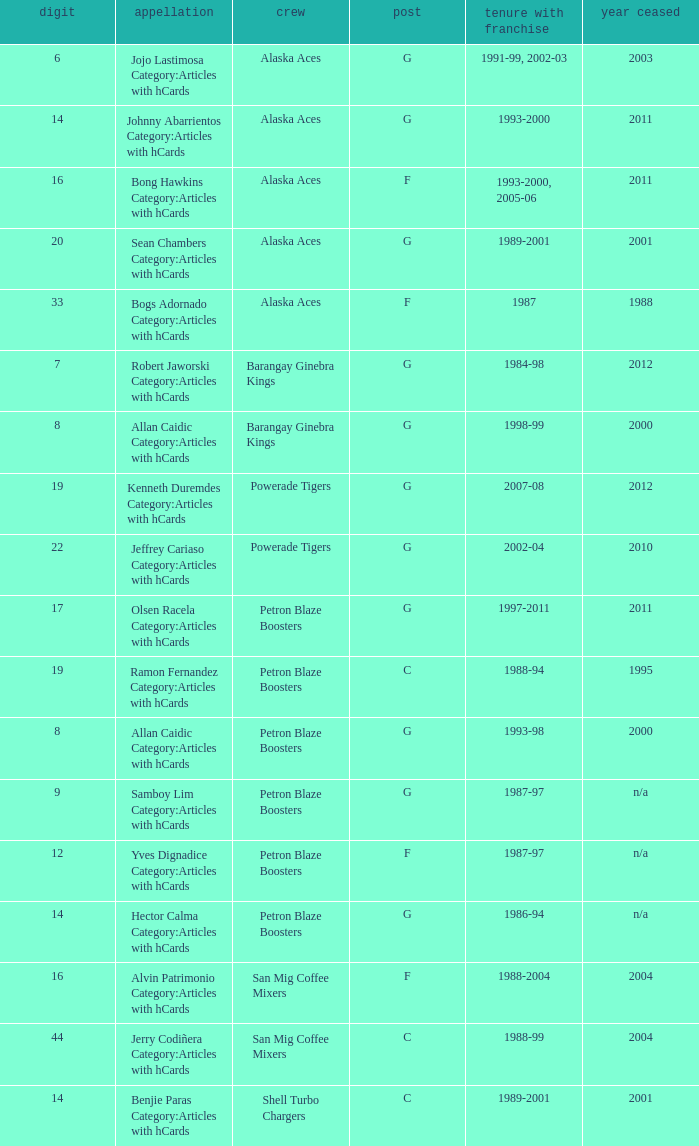Who was the player in Position G on the Petron Blaze Boosters and retired in 2000? Allan Caidic Category:Articles with hCards. 